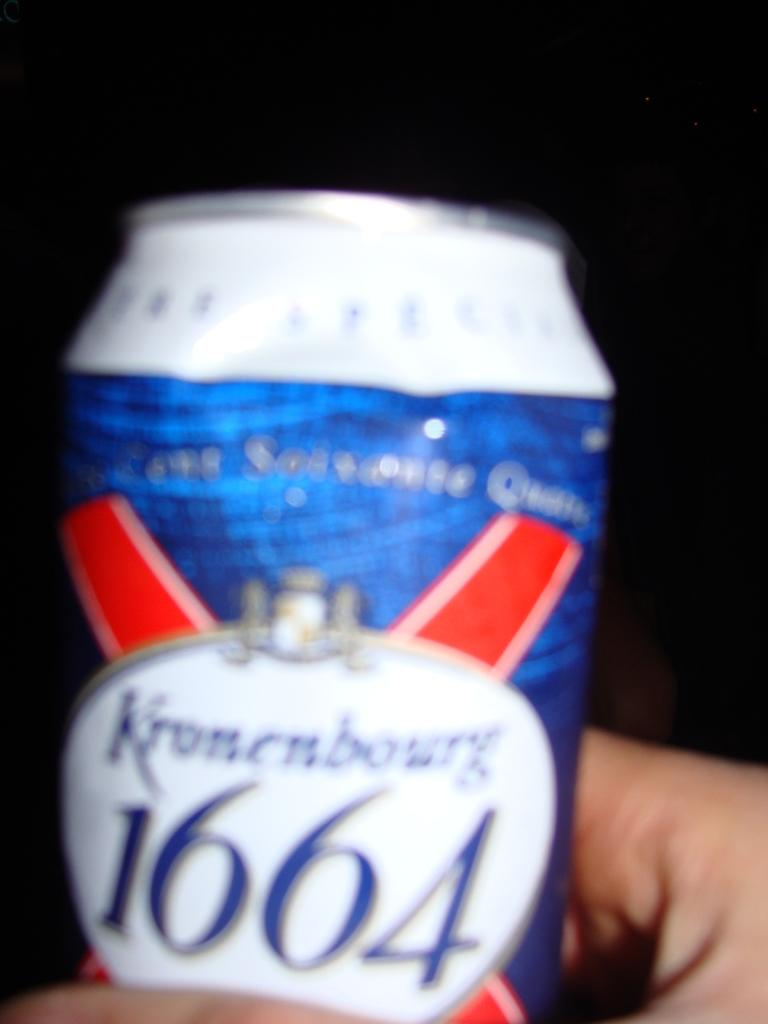<image>
Render a clear and concise summary of the photo. A can with blue, red and white reads Kronenbourg 1664 on the front. 